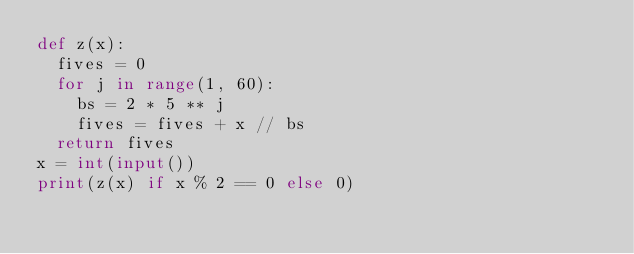Convert code to text. <code><loc_0><loc_0><loc_500><loc_500><_Python_>def z(x):
  fives = 0
  for j in range(1, 60):
    bs = 2 * 5 ** j
    fives = fives + x // bs
  return fives
x = int(input())
print(z(x) if x % 2 == 0 else 0)</code> 